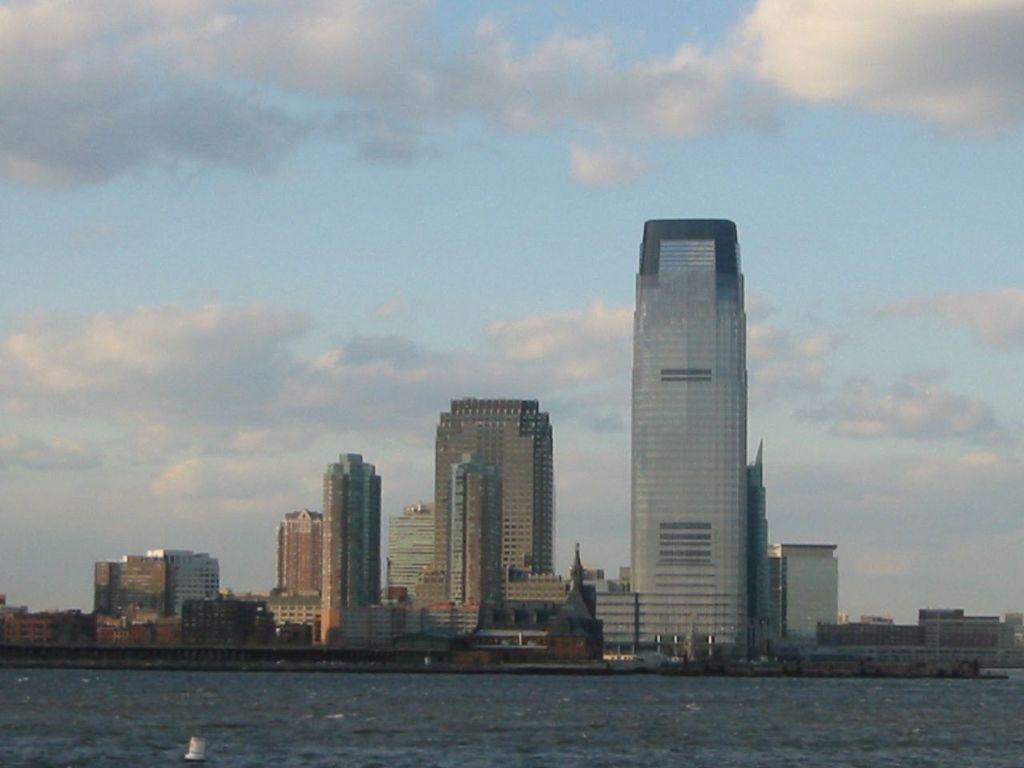Describe this image in one or two sentences. This picture is clicked outside the city. At the bottom of the picture, we see water and this water might be in the lake or in the river. In the background, we see a statue. There are many buildings in the background. At the top of the picture, we see the sky and the clouds. 